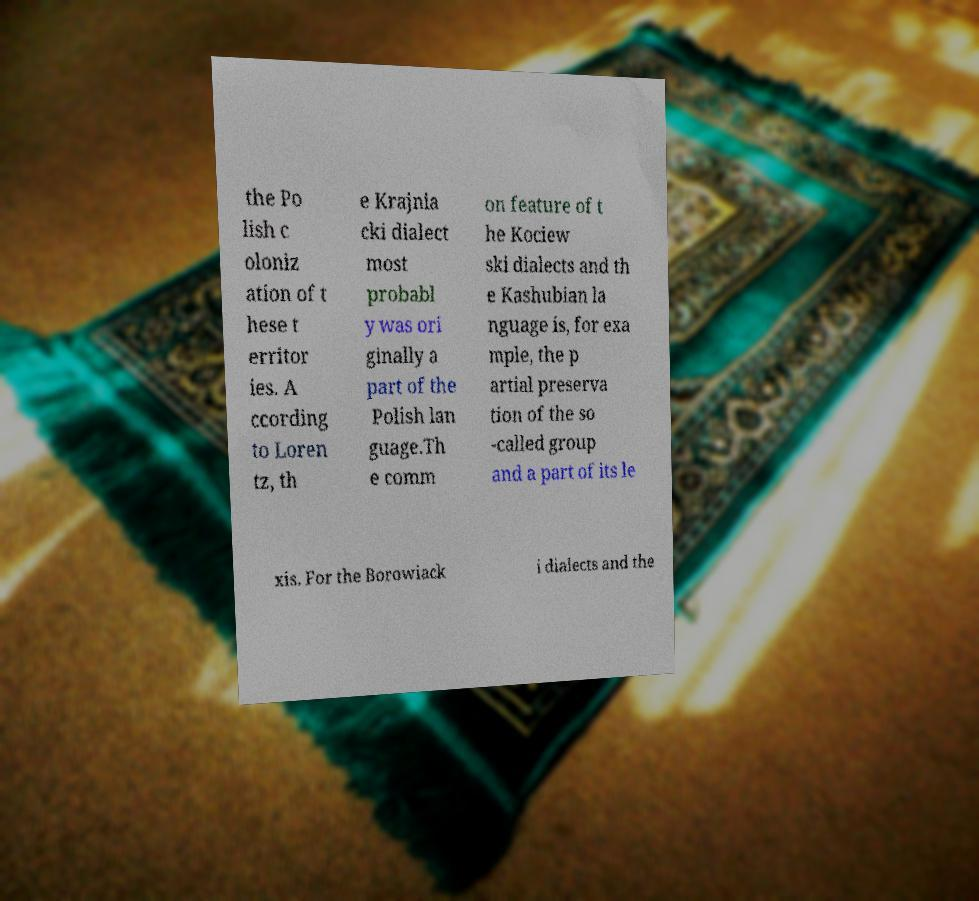Could you assist in decoding the text presented in this image and type it out clearly? the Po lish c oloniz ation of t hese t erritor ies. A ccording to Loren tz, th e Krajnia cki dialect most probabl y was ori ginally a part of the Polish lan guage.Th e comm on feature of t he Kociew ski dialects and th e Kashubian la nguage is, for exa mple, the p artial preserva tion of the so -called group and a part of its le xis. For the Borowiack i dialects and the 